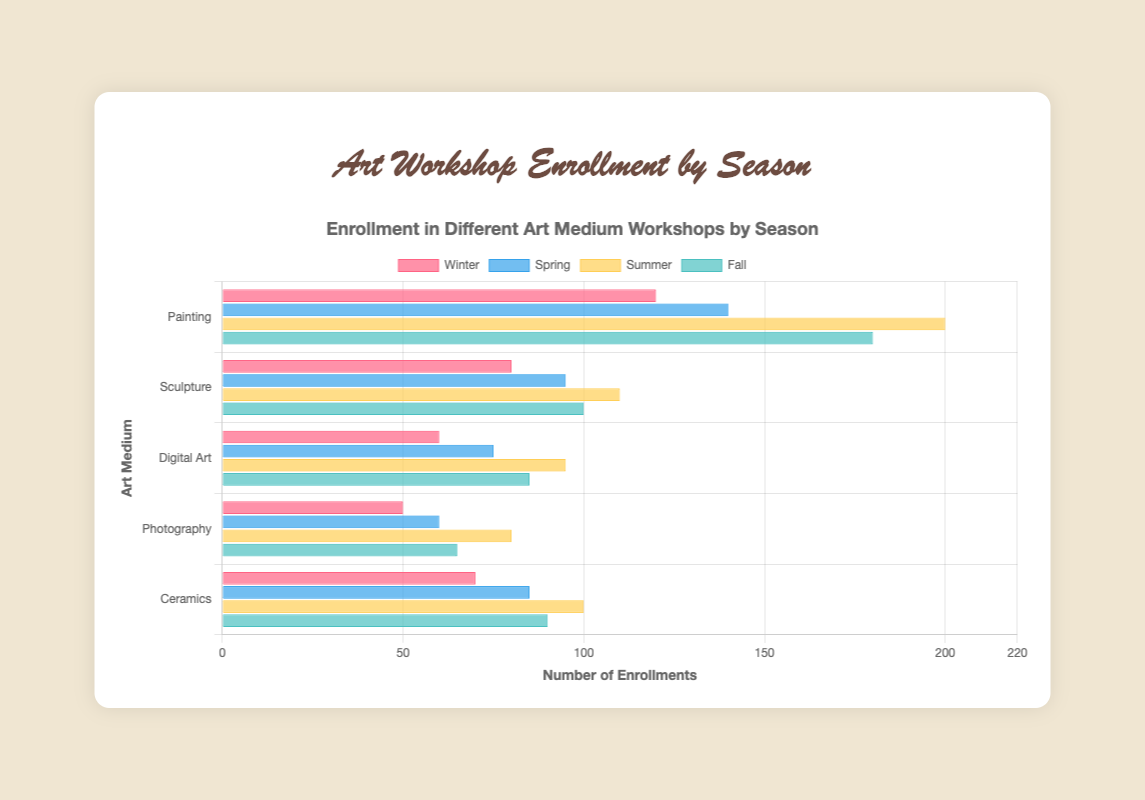How many more enrollments does Painting have in Summer than in Winter? Compare the enrollments of Painting in Summer (200) with those in Winter (120). Subtract the Winter enrollments from the Summer enrollments: 200 - 120 = 80.
Answer: 80 Which art medium has the lowest enrollment in Fall? From the Fall data, compare the enrollments across different mediums: Painting (180), Sculpture (100), Digital Art (85), Photography (65), Ceramics (90). Photography has the lowest enrollment.
Answer: Photography What is the total enrollment for all art mediums in Spring? Sum up all the enrollments for Spring: Painting (140) + Sculpture (95) + Digital Art (75) + Photography (60) + Ceramics (85). The total is 140 + 95 + 75 + 60 + 85 = 455.
Answer: 455 How many more enrollments does Sculpture have in Fall compared to Winter? Compare the enrollments of Sculpture in Fall (100) with those in Winter (80). Subtract the Winter enrollments from the Fall enrollments: 100 - 80 = 20.
Answer: 20 Which season has the highest enrollment for Digital Art? Compare the Digital Art enrollments across seasons: Winter (60), Spring (75), Summer (95), Fall (85). Summer has the highest enrollment.
Answer: Summer By how much does Photography enrollment increase from Winter to Summer? Compare the Photography enrollments in Winter (50) and Summer (80). Subtract the Winter enrollments from the Summer enrollments: 80 - 50 = 30.
Answer: 30 Which art medium has the highest total enrollment across all seasons? Calculate the total enrollment for each medium across all seasons:
- Painting: 120 (W) + 140 (Sp) + 200 (Su) + 180 (F) = 640
- Sculpture: 80 (W) + 95 (Sp) + 110 (Su) + 100 (F) = 385
- Digital Art: 60 (W) + 75 (Sp) + 95 (Su) + 85 (F) = 315
- Photography: 50 (W) + 60 (Sp) + 80 (Su) + 65 (F) = 255
- Ceramics: 70 (W) + 85 (Sp) + 100 (Su) + 90 (F) = 345
Painting has the highest total enrollment.
Answer: Painting What is the average enrollment for Ceramics across all seasons? Calculate the total enrollment for Ceramics across all seasons and divide by the number of seasons: 
70 (W) + 85 (Sp) + 100 (Su) + 90 (F) = 345. The average is 345 / 4 = 86.25.
Answer: 86.25 Which season has the least enrollment in Painting? Compare the enrollments for Painting across seasons: Winter (120), Spring (140), Summer (200), Fall (180). Winter has the least enrollment.
Answer: Winter 